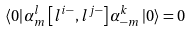<formula> <loc_0><loc_0><loc_500><loc_500>\left \langle 0 \right | \alpha _ { m } ^ { l } \left [ l ^ { i - } , l ^ { j - } \right ] \alpha _ { - m } ^ { k } \left | 0 \right \rangle = 0</formula> 